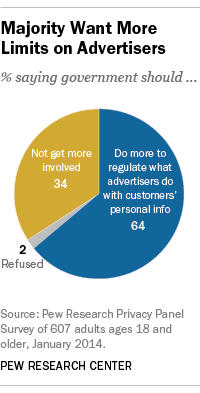Highlight a few significant elements in this photo. The value of Refused segment 2 is Yes. The difference between the two largest segments is even. 